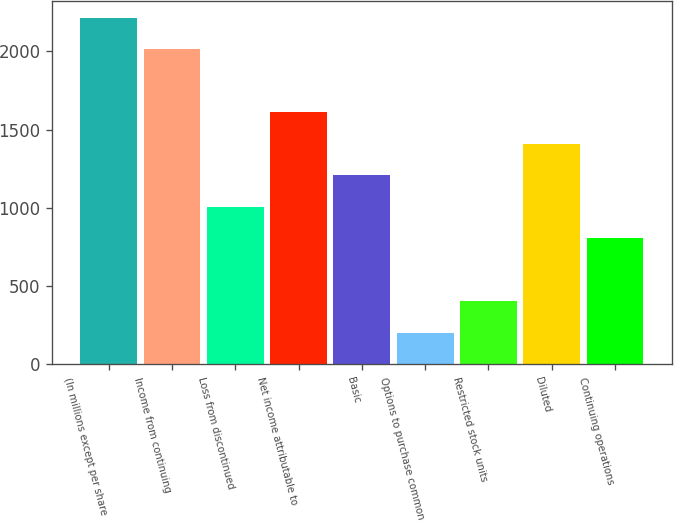<chart> <loc_0><loc_0><loc_500><loc_500><bar_chart><fcel>(In millions except per share<fcel>Income from continuing<fcel>Loss from discontinued<fcel>Net income attributable to<fcel>Basic<fcel>Options to purchase common<fcel>Restricted stock units<fcel>Diluted<fcel>Continuing operations<nl><fcel>2214.29<fcel>2013<fcel>1006.55<fcel>1610.42<fcel>1207.84<fcel>201.39<fcel>402.68<fcel>1409.13<fcel>805.26<nl></chart> 